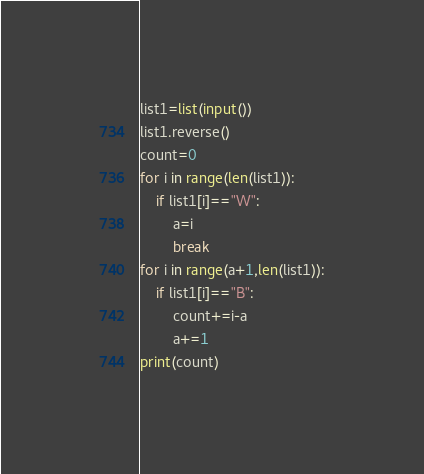<code> <loc_0><loc_0><loc_500><loc_500><_Python_>list1=list(input())
list1.reverse()
count=0
for i in range(len(list1)):
    if list1[i]=="W":
        a=i
        break
for i in range(a+1,len(list1)):
    if list1[i]=="B":
        count+=i-a
        a+=1
print(count)</code> 